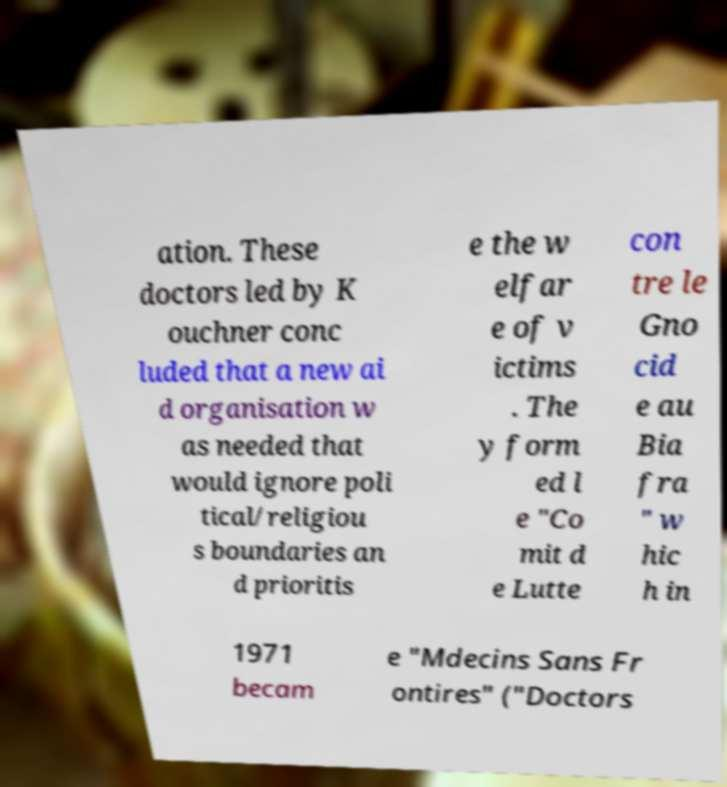Can you read and provide the text displayed in the image?This photo seems to have some interesting text. Can you extract and type it out for me? ation. These doctors led by K ouchner conc luded that a new ai d organisation w as needed that would ignore poli tical/religiou s boundaries an d prioritis e the w elfar e of v ictims . The y form ed l e "Co mit d e Lutte con tre le Gno cid e au Bia fra " w hic h in 1971 becam e "Mdecins Sans Fr ontires" ("Doctors 